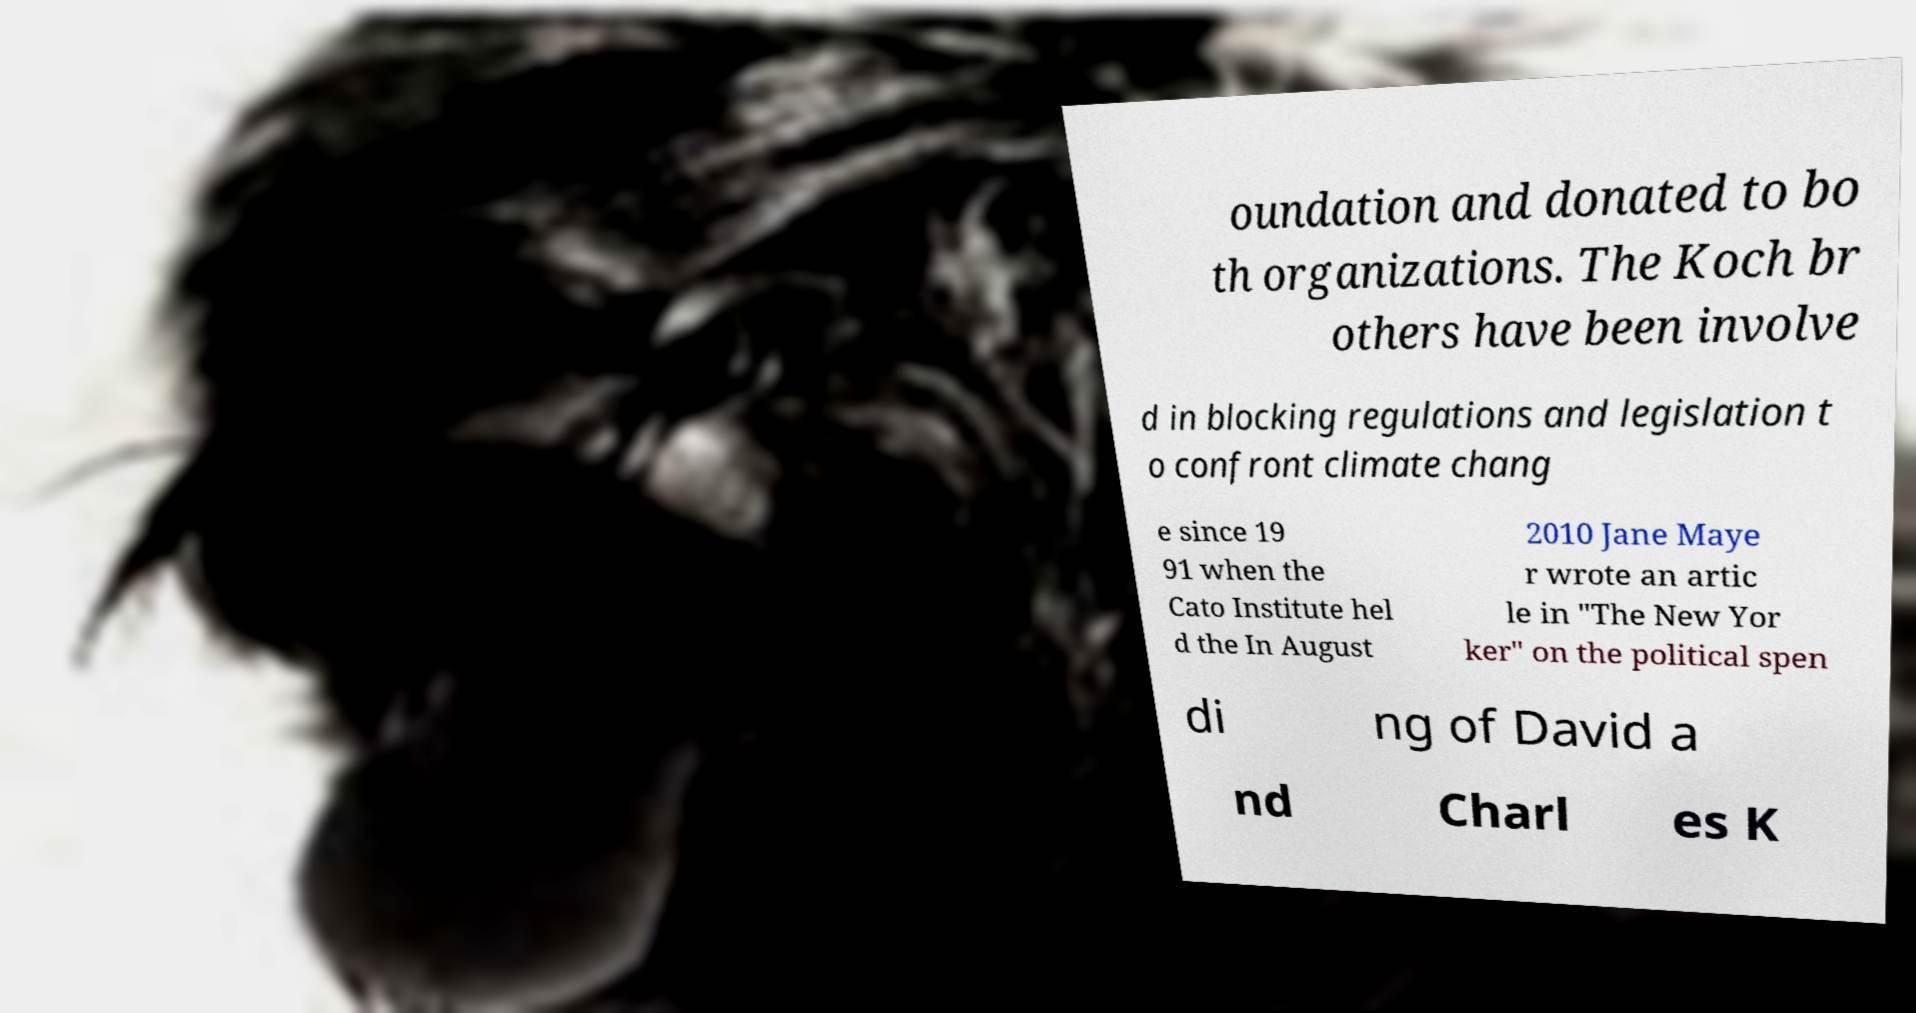Could you extract and type out the text from this image? oundation and donated to bo th organizations. The Koch br others have been involve d in blocking regulations and legislation t o confront climate chang e since 19 91 when the Cato Institute hel d the In August 2010 Jane Maye r wrote an artic le in "The New Yor ker" on the political spen di ng of David a nd Charl es K 